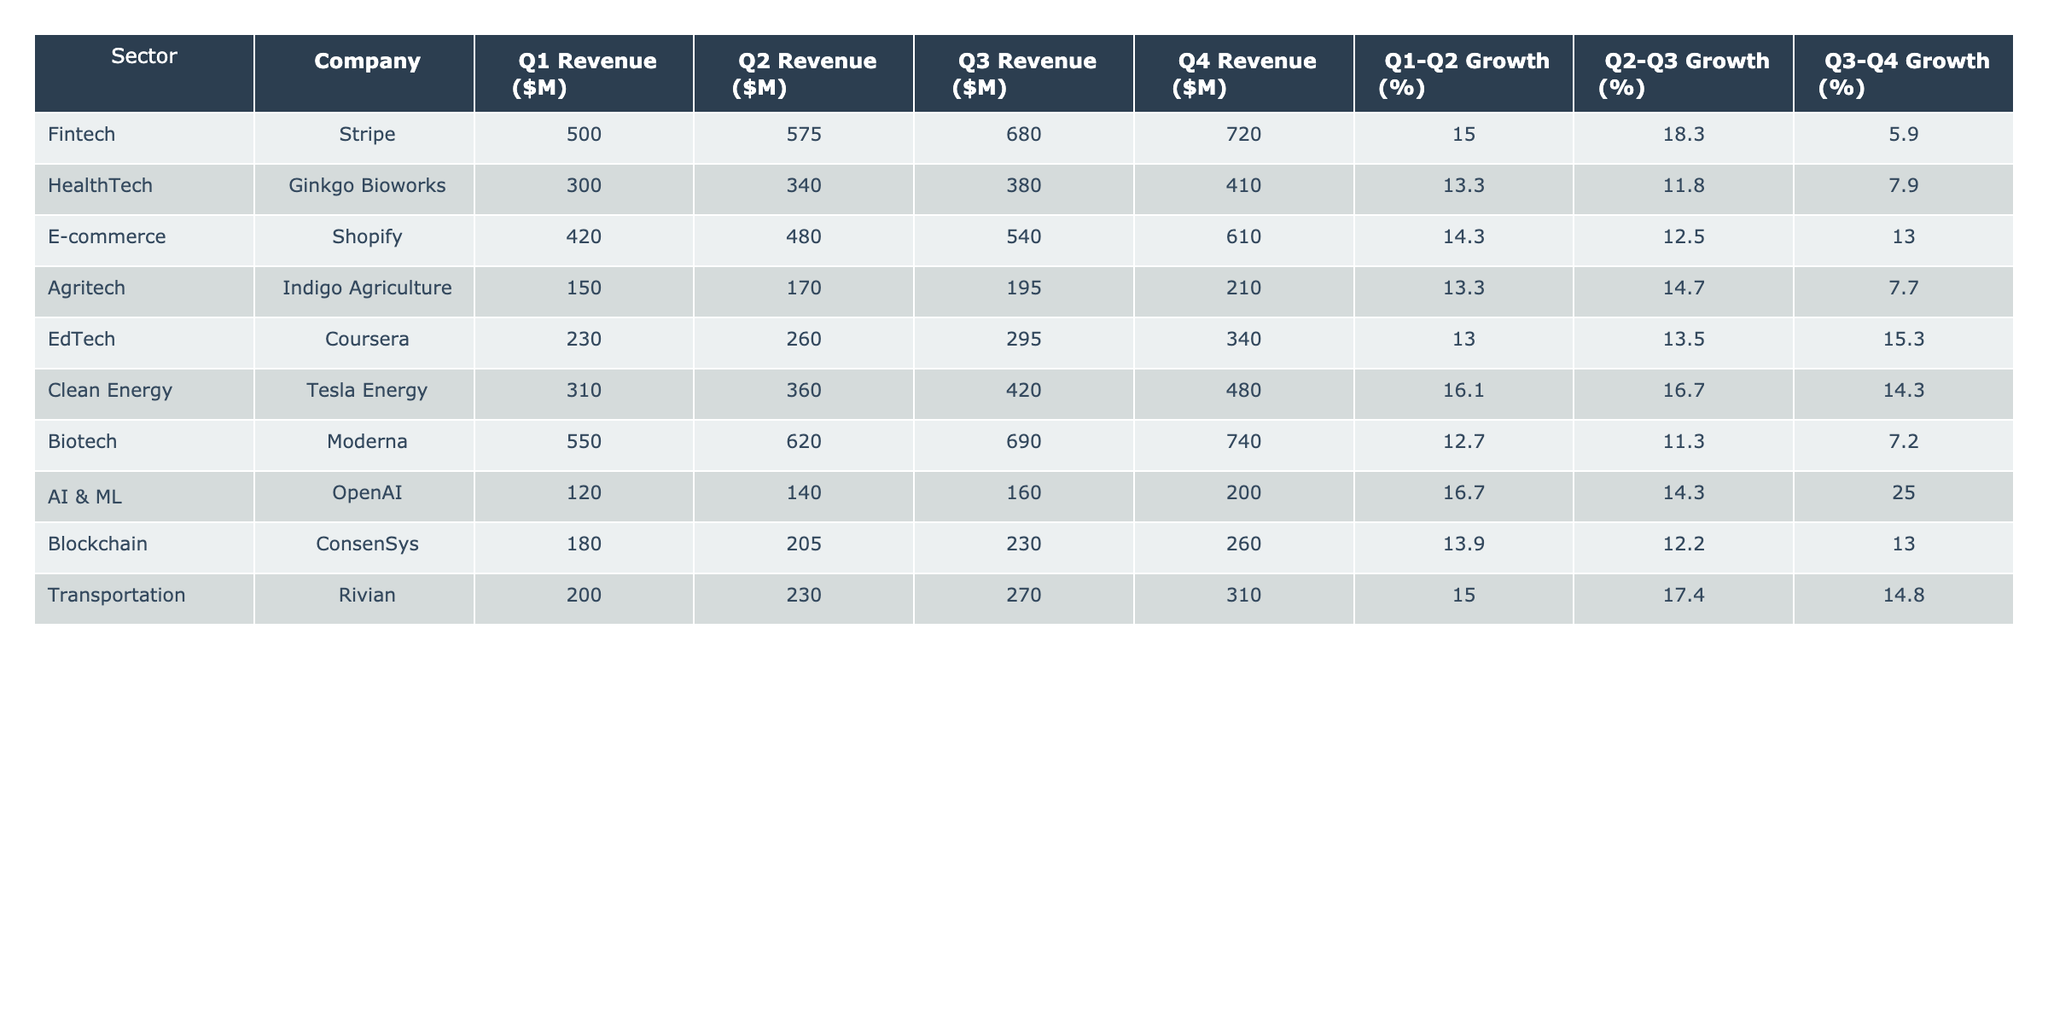What is the total revenue for Stripe across all four quarters? To find the total revenue for Stripe, we need to add up the revenue for each quarter: 500 + 575 + 680 + 720 = 2975 million dollars.
Answer: 2975 million dollars Which sector shows the highest growth percentage from Q1 to Q2? We compare the Q1-Q2 growth percentages across sectors: Fintech (15.0), HealthTech (13.3), E-commerce (14.3), Agritech (13.3), EdTech (13.0), Clean Energy (16.1), Biotech (12.7), AI & ML (16.7), Blockchain (13.9), Transportation (15.0). The highest is Clean Energy with 16.1%.
Answer: Clean Energy Does Moderna have a higher Q4 revenue than Ginkgo Bioworks? Looking at the Q4 revenue: Moderna has 740 million dollars, while Ginkgo Bioworks has 410 million dollars. Since 740 is greater than 410, the statement is true.
Answer: Yes What is the average Q3 revenue for all sectors? To calculate the average, sum the Q3 revenues: 680 + 380 + 540 + 195 + 295 + 420 + 690 + 160 + 230 + 270 = 3760 million dollars. Then we divide by the number of sectors (10): 3760 / 10 = 376 million dollars.
Answer: 376 million dollars Which company experienced the lowest growth percentage from Q3 to Q4? We examine the Q3-Q4 growth percentages: Fintech (5.9), HealthTech (7.9), E-commerce (13.0), Agritech (7.7), EdTech (15.3), Clean Energy (14.3), Biotech (7.2), AI & ML (25.0), Blockchain (13.0), Transportation (14.8). The lowest is Biotech with 7.2%.
Answer: Biotech What is the overall growth trend from Q1 to Q4 for Transportation? Transportation's revenues are: Q1: 200, Q2: 230, Q3: 270, Q4: 310. We can see that it has increased consistently each quarter, with growth percentages of 15.0, 17.4, and 14.8 respectively.
Answer: Consistent growth Is the average Q2 revenue for both Fintech and E-commerce higher than that of HealthTech? Q2 revenues are Fintech (575), E-commerce (480), and HealthTech (340). The average for Fintech and E-commerce is (575 + 480) / 2 = 527.5, which is greater than 340. So, the statement is true.
Answer: Yes What is the difference between the highest and lowest Q3 revenues among the listed companies? The highest Q3 revenue is from Moderna (690 million) and the lowest from AI & ML (160 million). The difference is 690 - 160 = 530 million dollars.
Answer: 530 million dollars Which sector should be considered the fastest growing based on its Q1 to Q4 growth rates? We review the total growth over four quarters for the fastest growth sector. For AI & ML: 120 to 200 (a 66.7% increase). Comparatively, other sectors showed lower overall percentages in relative growth. AI & ML shows the steepest growth, especially in Q3 to Q4.
Answer: AI & ML 